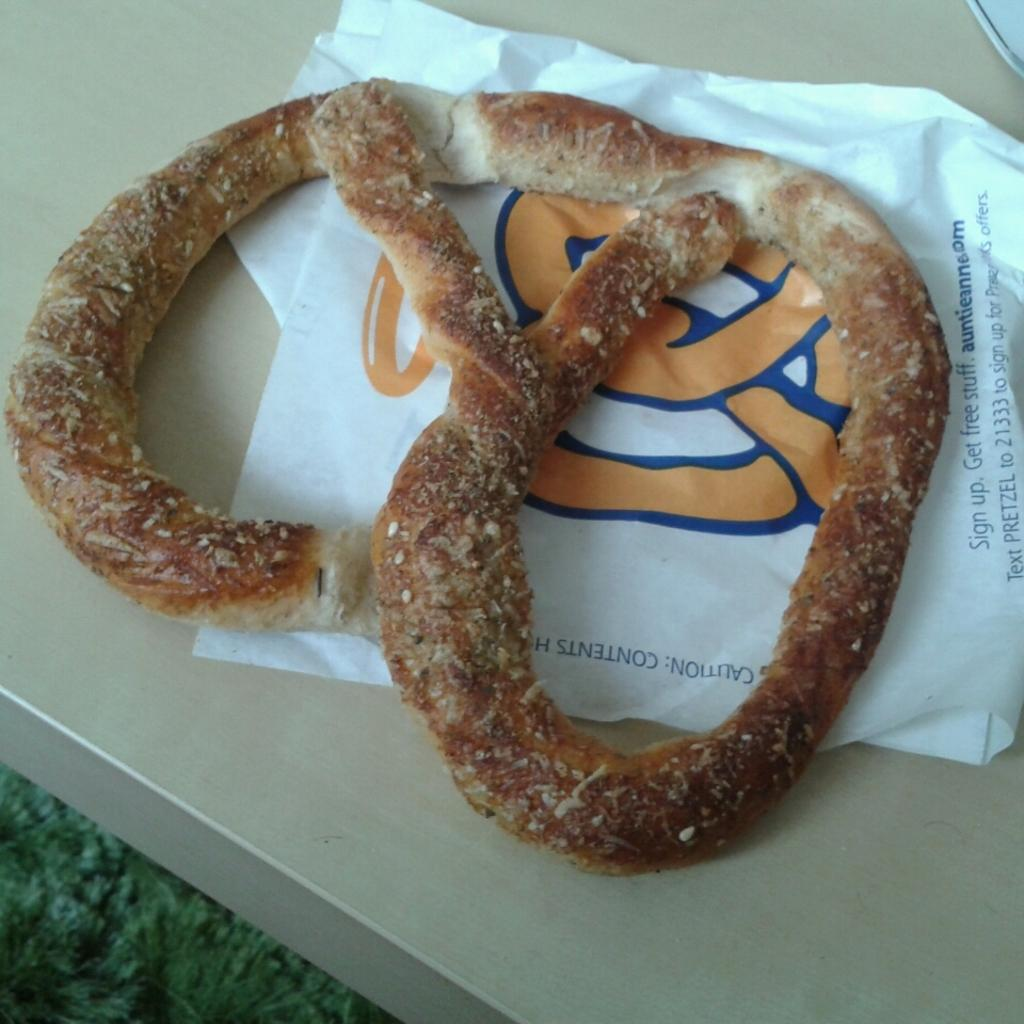What is the main subject of the image? The main subject of the image is food. Can you describe any other objects present in the image? Yes, there is a paper bag on the table in the image. How much money is inside the paper bag in the image? There is no mention of money or any financial transactions in the image; it only features food and a paper bag on the table. 